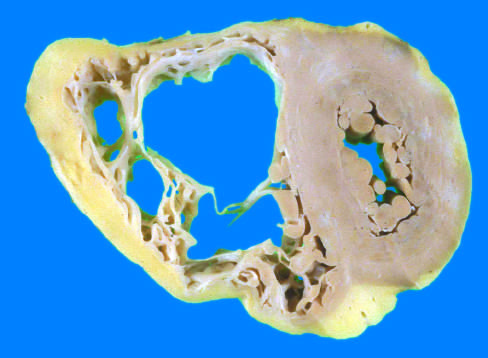s the right ventricle markedly dilated with focal, almost transmural replacement of the free wall by adipose tissue and fibrosis?
Answer the question using a single word or phrase. Yes 